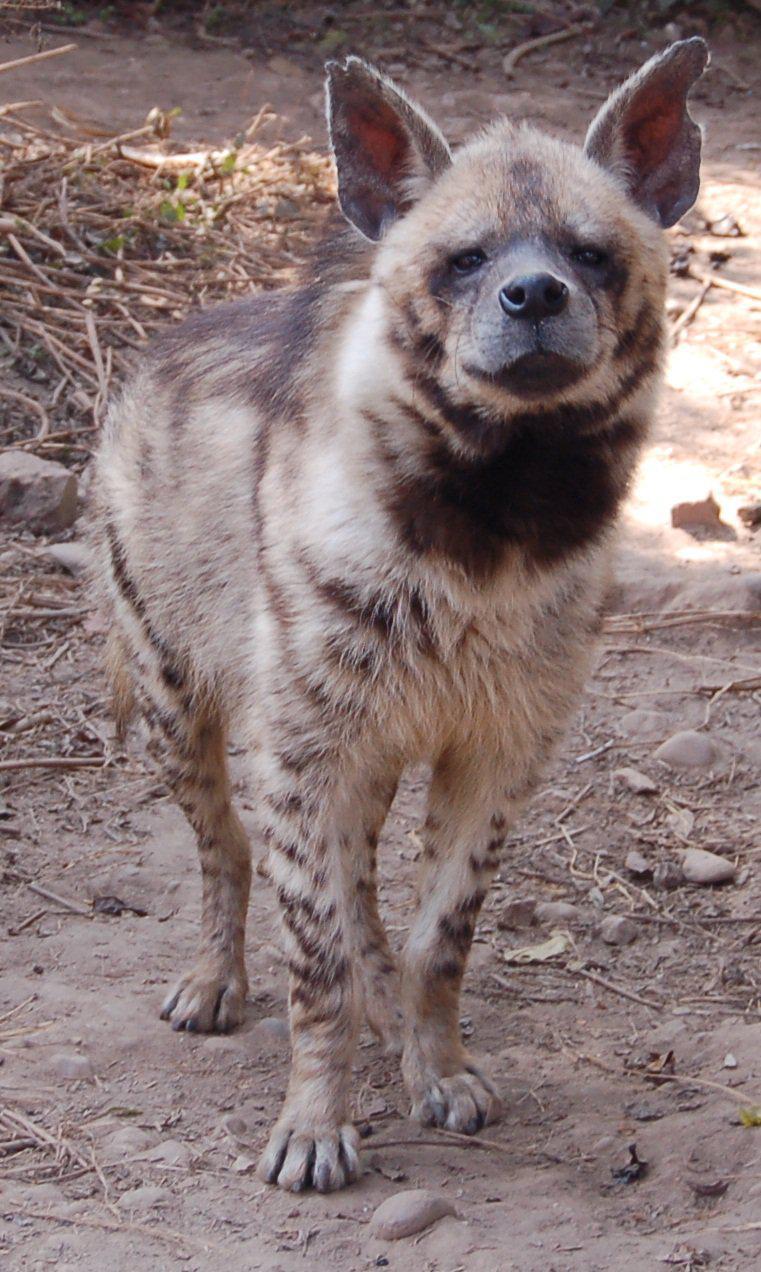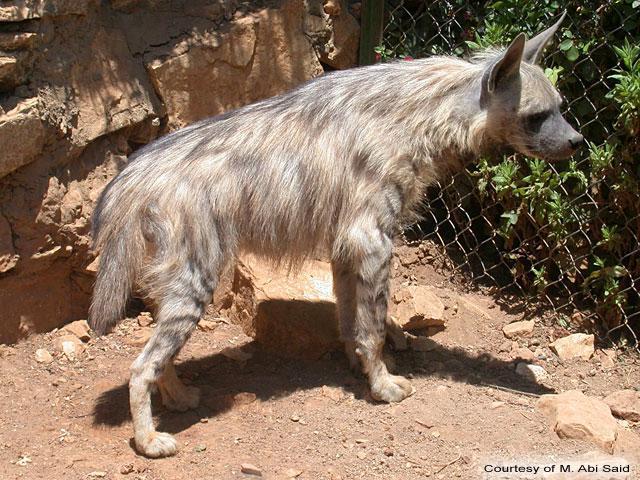The first image is the image on the left, the second image is the image on the right. For the images shown, is this caption "Some of the hyenas are laying down." true? Answer yes or no. No. 